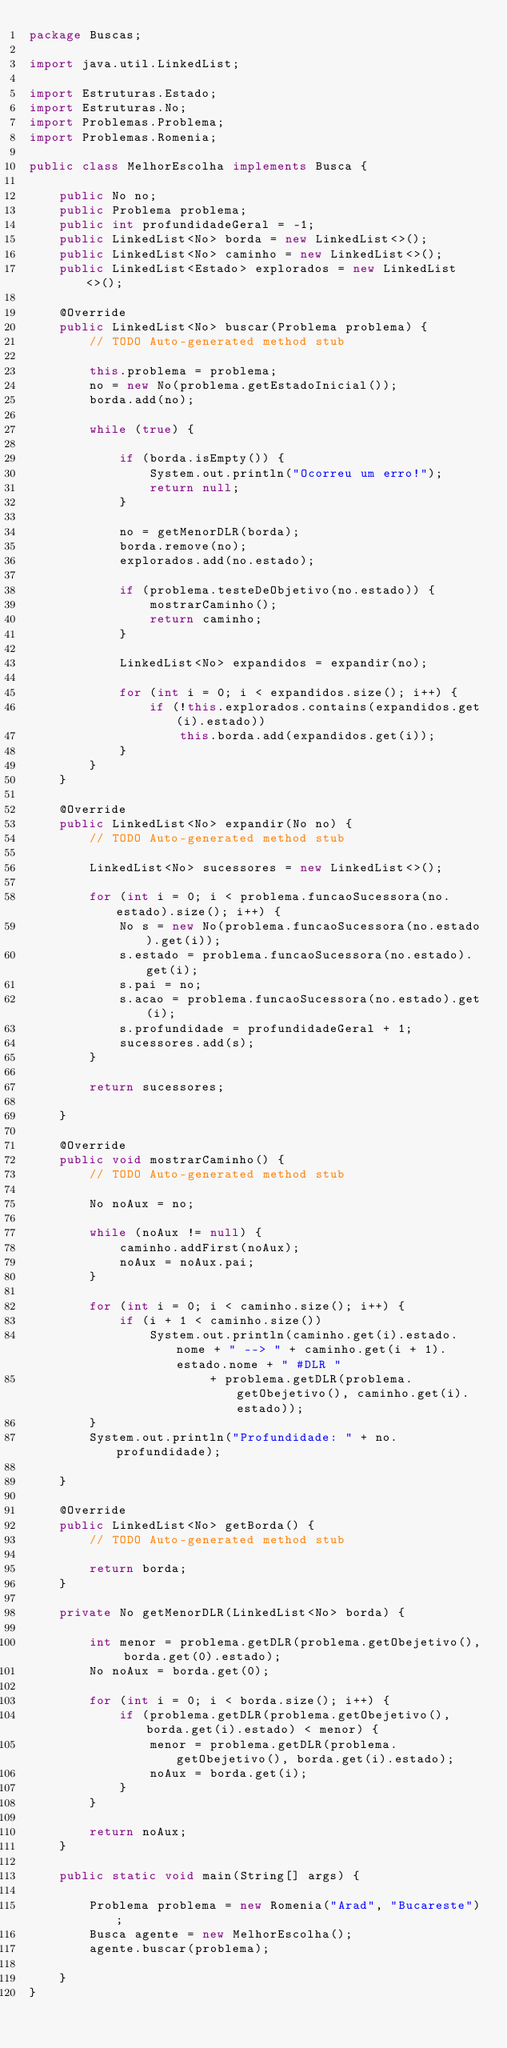Convert code to text. <code><loc_0><loc_0><loc_500><loc_500><_Java_>package Buscas;

import java.util.LinkedList;

import Estruturas.Estado;
import Estruturas.No;
import Problemas.Problema;
import Problemas.Romenia;

public class MelhorEscolha implements Busca {

	public No no;
	public Problema problema;
	public int profundidadeGeral = -1;
	public LinkedList<No> borda = new LinkedList<>();
	public LinkedList<No> caminho = new LinkedList<>();
	public LinkedList<Estado> explorados = new LinkedList<>();

	@Override
	public LinkedList<No> buscar(Problema problema) {
		// TODO Auto-generated method stub

		this.problema = problema;
		no = new No(problema.getEstadoInicial());
		borda.add(no);

		while (true) {

			if (borda.isEmpty()) {
				System.out.println("Ocorreu um erro!");
				return null;
			}

			no = getMenorDLR(borda);
			borda.remove(no);
			explorados.add(no.estado);

			if (problema.testeDeObjetivo(no.estado)) {
				mostrarCaminho();
				return caminho;
			}

			LinkedList<No> expandidos = expandir(no);

			for (int i = 0; i < expandidos.size(); i++) {
				if (!this.explorados.contains(expandidos.get(i).estado))
					this.borda.add(expandidos.get(i));
			}
		}
	}

	@Override
	public LinkedList<No> expandir(No no) {
		// TODO Auto-generated method stub

		LinkedList<No> sucessores = new LinkedList<>();

		for (int i = 0; i < problema.funcaoSucessora(no.estado).size(); i++) {
			No s = new No(problema.funcaoSucessora(no.estado).get(i));
			s.estado = problema.funcaoSucessora(no.estado).get(i);
			s.pai = no;
			s.acao = problema.funcaoSucessora(no.estado).get(i);
			s.profundidade = profundidadeGeral + 1;
			sucessores.add(s);
		}

		return sucessores;

	}

	@Override
	public void mostrarCaminho() {
		// TODO Auto-generated method stub

		No noAux = no;

		while (noAux != null) {
			caminho.addFirst(noAux);
			noAux = noAux.pai;
		}

		for (int i = 0; i < caminho.size(); i++) {
			if (i + 1 < caminho.size())
				System.out.println(caminho.get(i).estado.nome + " --> " + caminho.get(i + 1).estado.nome + " #DLR "
						+ problema.getDLR(problema.getObejetivo(), caminho.get(i).estado));
		}
		System.out.println("Profundidade: " + no.profundidade);

	}

	@Override
	public LinkedList<No> getBorda() {
		// TODO Auto-generated method stub

		return borda;
	}

	private No getMenorDLR(LinkedList<No> borda) {

		int menor = problema.getDLR(problema.getObejetivo(), borda.get(0).estado);
		No noAux = borda.get(0);

		for (int i = 0; i < borda.size(); i++) {
			if (problema.getDLR(problema.getObejetivo(), borda.get(i).estado) < menor) {
				menor = problema.getDLR(problema.getObejetivo(), borda.get(i).estado);
				noAux = borda.get(i);
			}
		}

		return noAux;
	}

	public static void main(String[] args) {

		Problema problema = new Romenia("Arad", "Bucareste");
		Busca agente = new MelhorEscolha();
		agente.buscar(problema);

	}
}
</code> 